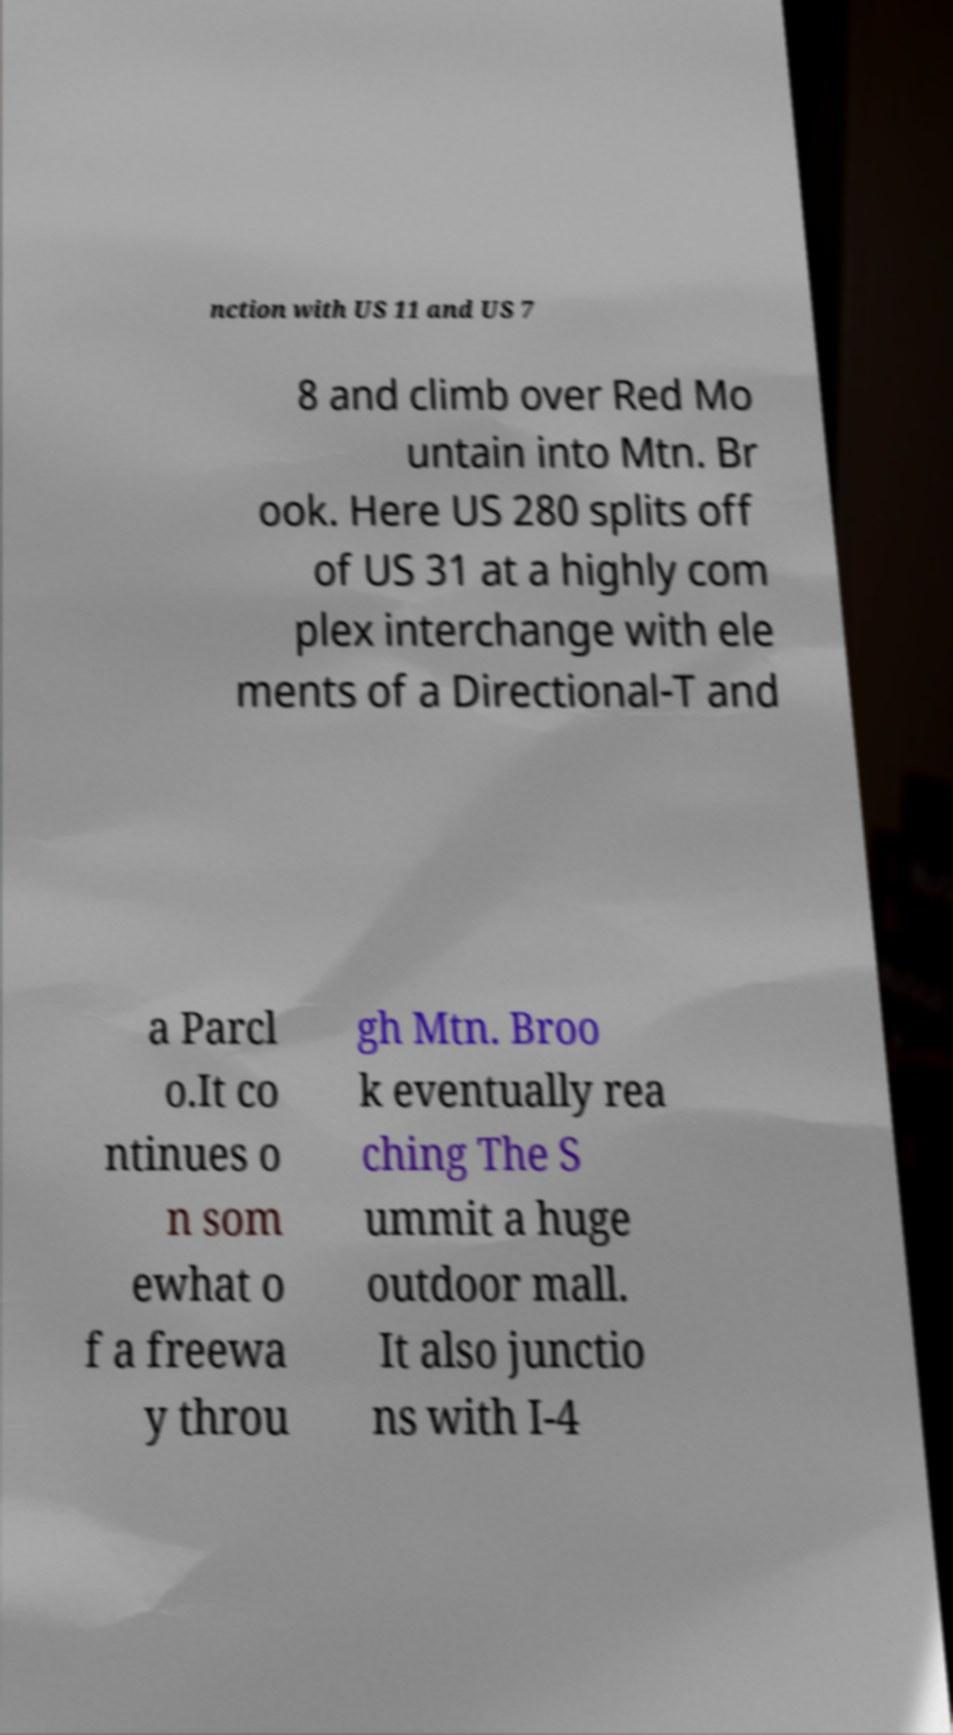What messages or text are displayed in this image? I need them in a readable, typed format. nction with US 11 and US 7 8 and climb over Red Mo untain into Mtn. Br ook. Here US 280 splits off of US 31 at a highly com plex interchange with ele ments of a Directional-T and a Parcl o.It co ntinues o n som ewhat o f a freewa y throu gh Mtn. Broo k eventually rea ching The S ummit a huge outdoor mall. It also junctio ns with I-4 